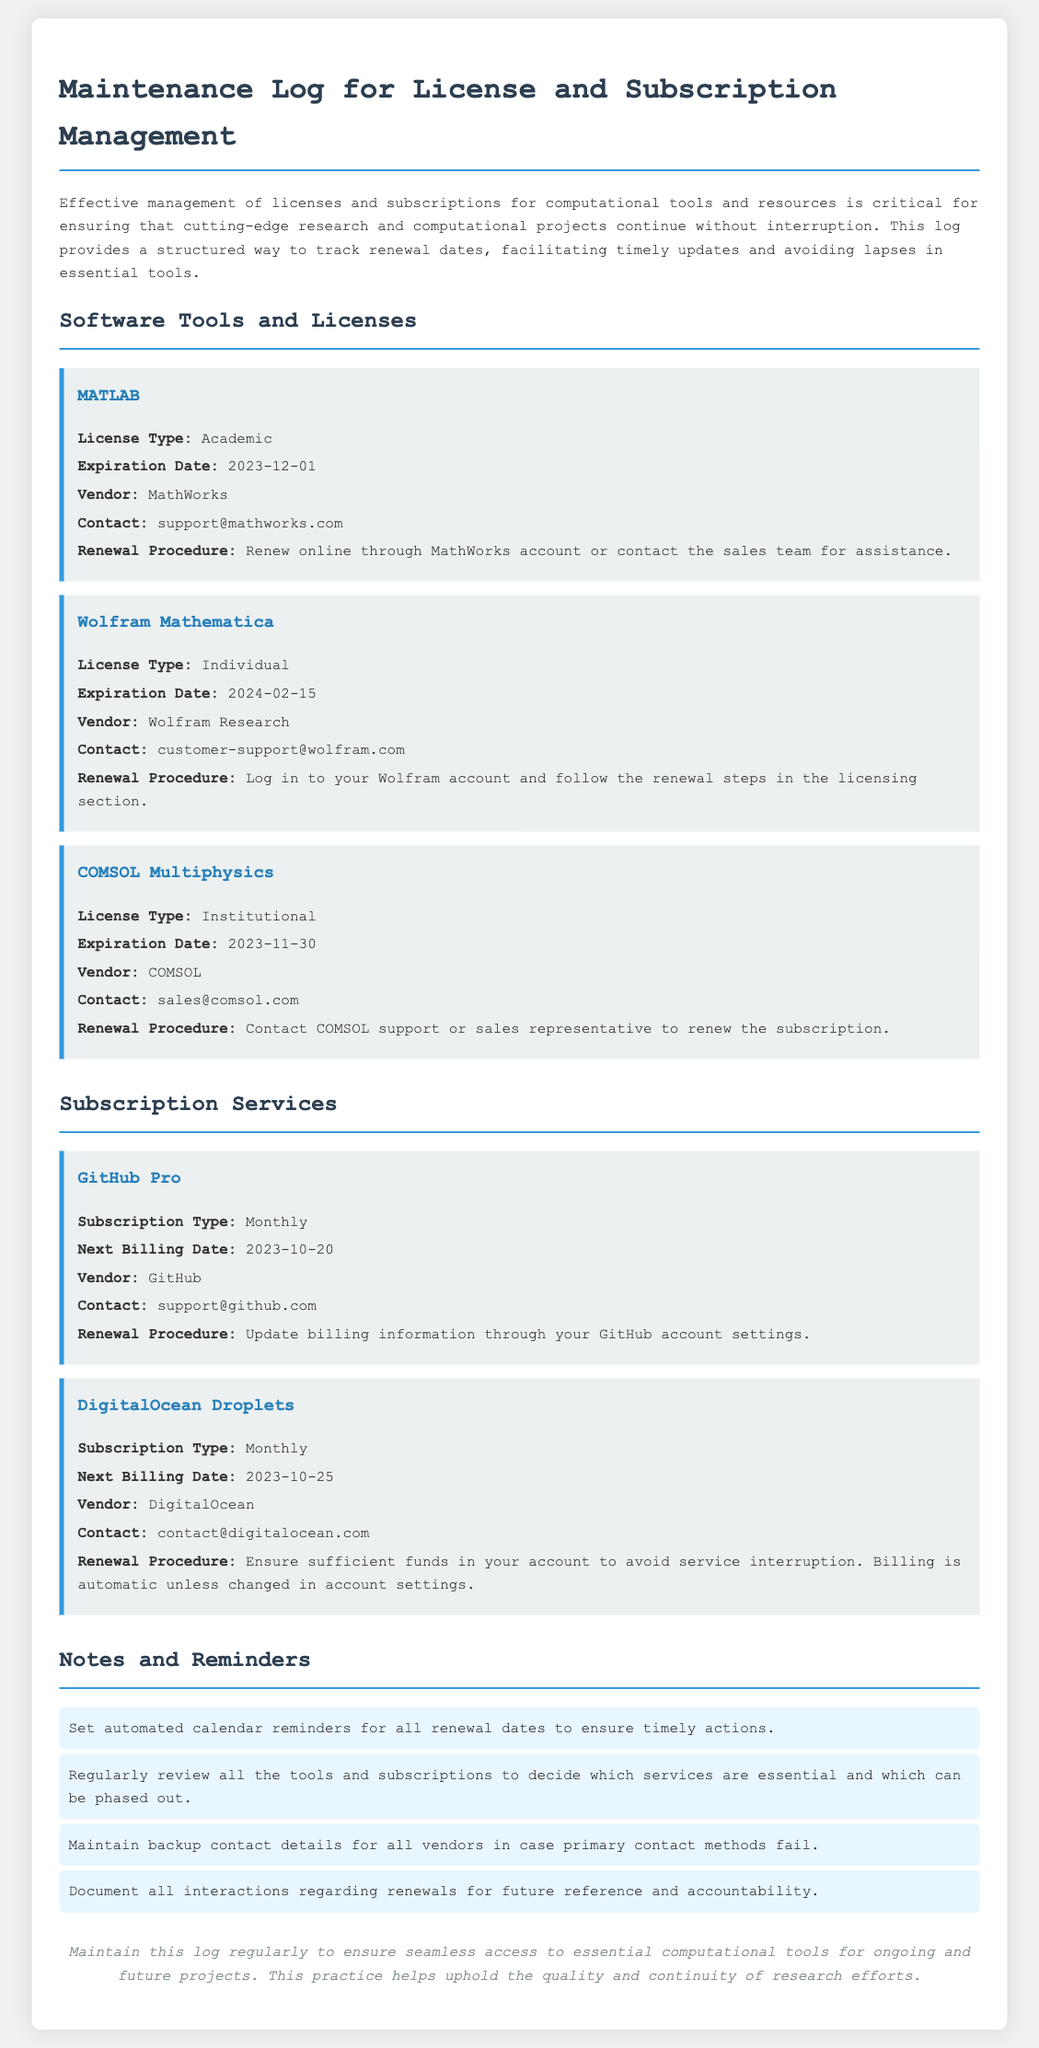What is the expiration date of MATLAB? The expiration date of MATLAB is explicitly mentioned in the document as 2023-12-01.
Answer: 2023-12-01 Who is the vendor for COMSOL Multiphysics? The document lists COMSOL as the vendor for COMSOL Multiphysics.
Answer: COMSOL What is the renewal procedure for GitHub Pro? The document states that the renewal procedure for GitHub Pro is to update billing information through the GitHub account settings.
Answer: Update billing information through your GitHub account settings What type of license does Wolfram Mathematica have? The license type for Wolfram Mathematica is specified in the document as Individual.
Answer: Individual When is the next billing date for DigitalOcean Droplets? The next billing date for DigitalOcean Droplets is documented as 2023-10-25.
Answer: 2023-10-25 What reminder is suggested for renewal dates? The document suggests setting automated calendar reminders for all renewal dates to ensure timely actions.
Answer: Automated calendar reminders What should be maintained for vendor contact? The document advises maintaining backup contact details for all vendors in case primary contact methods fail.
Answer: Backup contact details What is the subscription type for GitHub Pro? The document indicates that the subscription type for GitHub Pro is Monthly.
Answer: Monthly What is the primary way to renew MATLAB? The primary way to renew MATLAB is to renew online through the MathWorks account or contact the sales team for assistance.
Answer: Renew online through MathWorks account or contact the sales team for assistance 